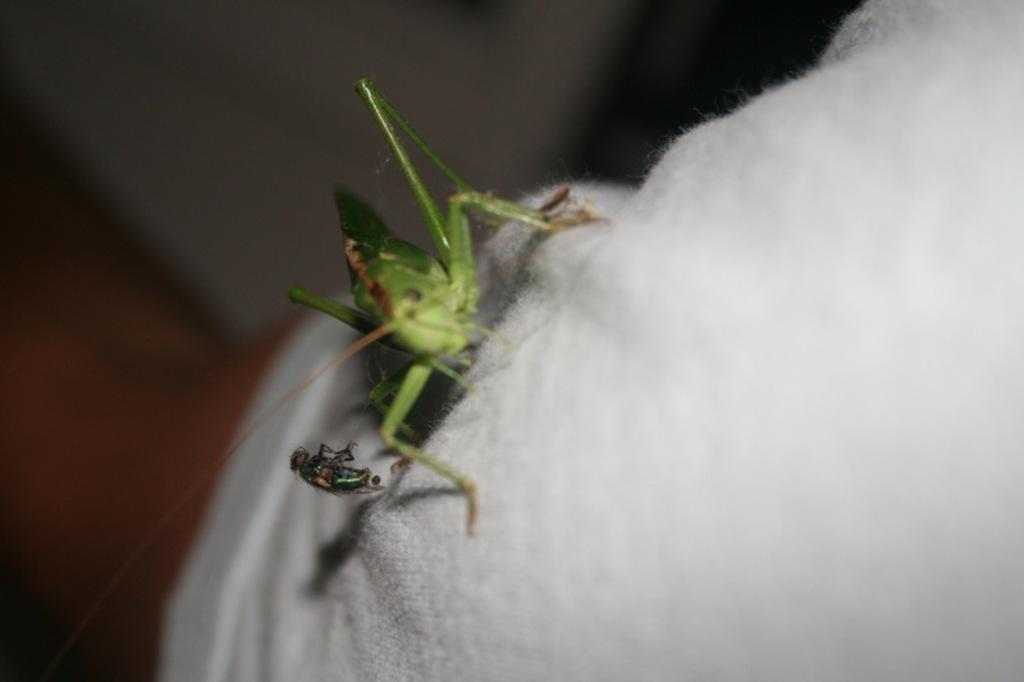How many insects are present in the image? There are two insects in the image. Where are the insects located? The insects are on a white cloth. Can you describe the background of the image? The background of the image is blurry. What type of journey are the mice taking in the image? There are no mice present in the image; it features two insects on a white cloth. How many mittens can be seen in the image? There are no mittens present in the image. 